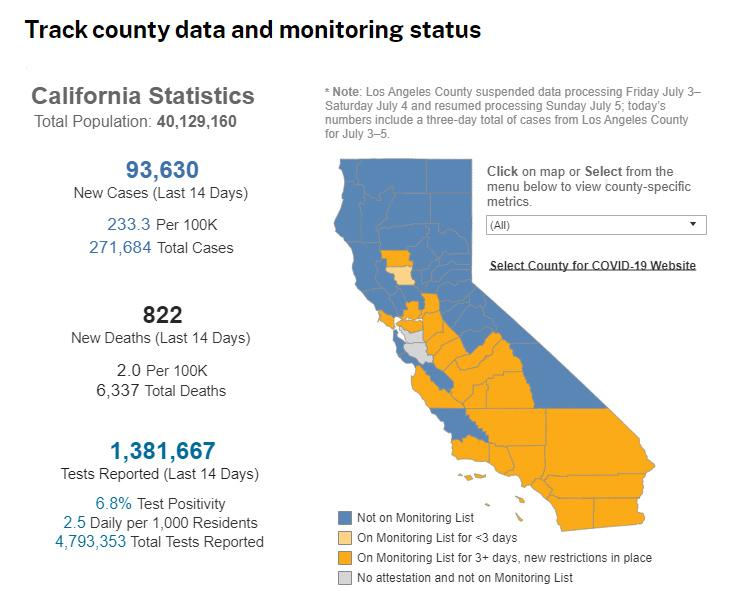Highlight a few significant elements in this photo. In the last 14 days, there have been 822 reported deaths. The total population and the number of tests reported in the last 14 days are two different measures. The total population refers to the total number of individuals in a particular population, while the number of tests reported in the last 14 days refers to the number of tests administered in a specific time frame. As of [date], the number of new cases has reached 93,630. The total number of tests reported is 3,411,686, while the number of tests reported in the last 14 days is also 3,411,686. 